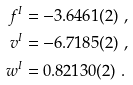Convert formula to latex. <formula><loc_0><loc_0><loc_500><loc_500>f ^ { I } & = - 3 . 6 4 6 1 ( 2 ) \ , \\ v ^ { I } & = - 6 . 7 1 8 5 ( 2 ) \ , \\ w ^ { I } & = 0 . 8 2 1 3 0 ( 2 ) \ .</formula> 